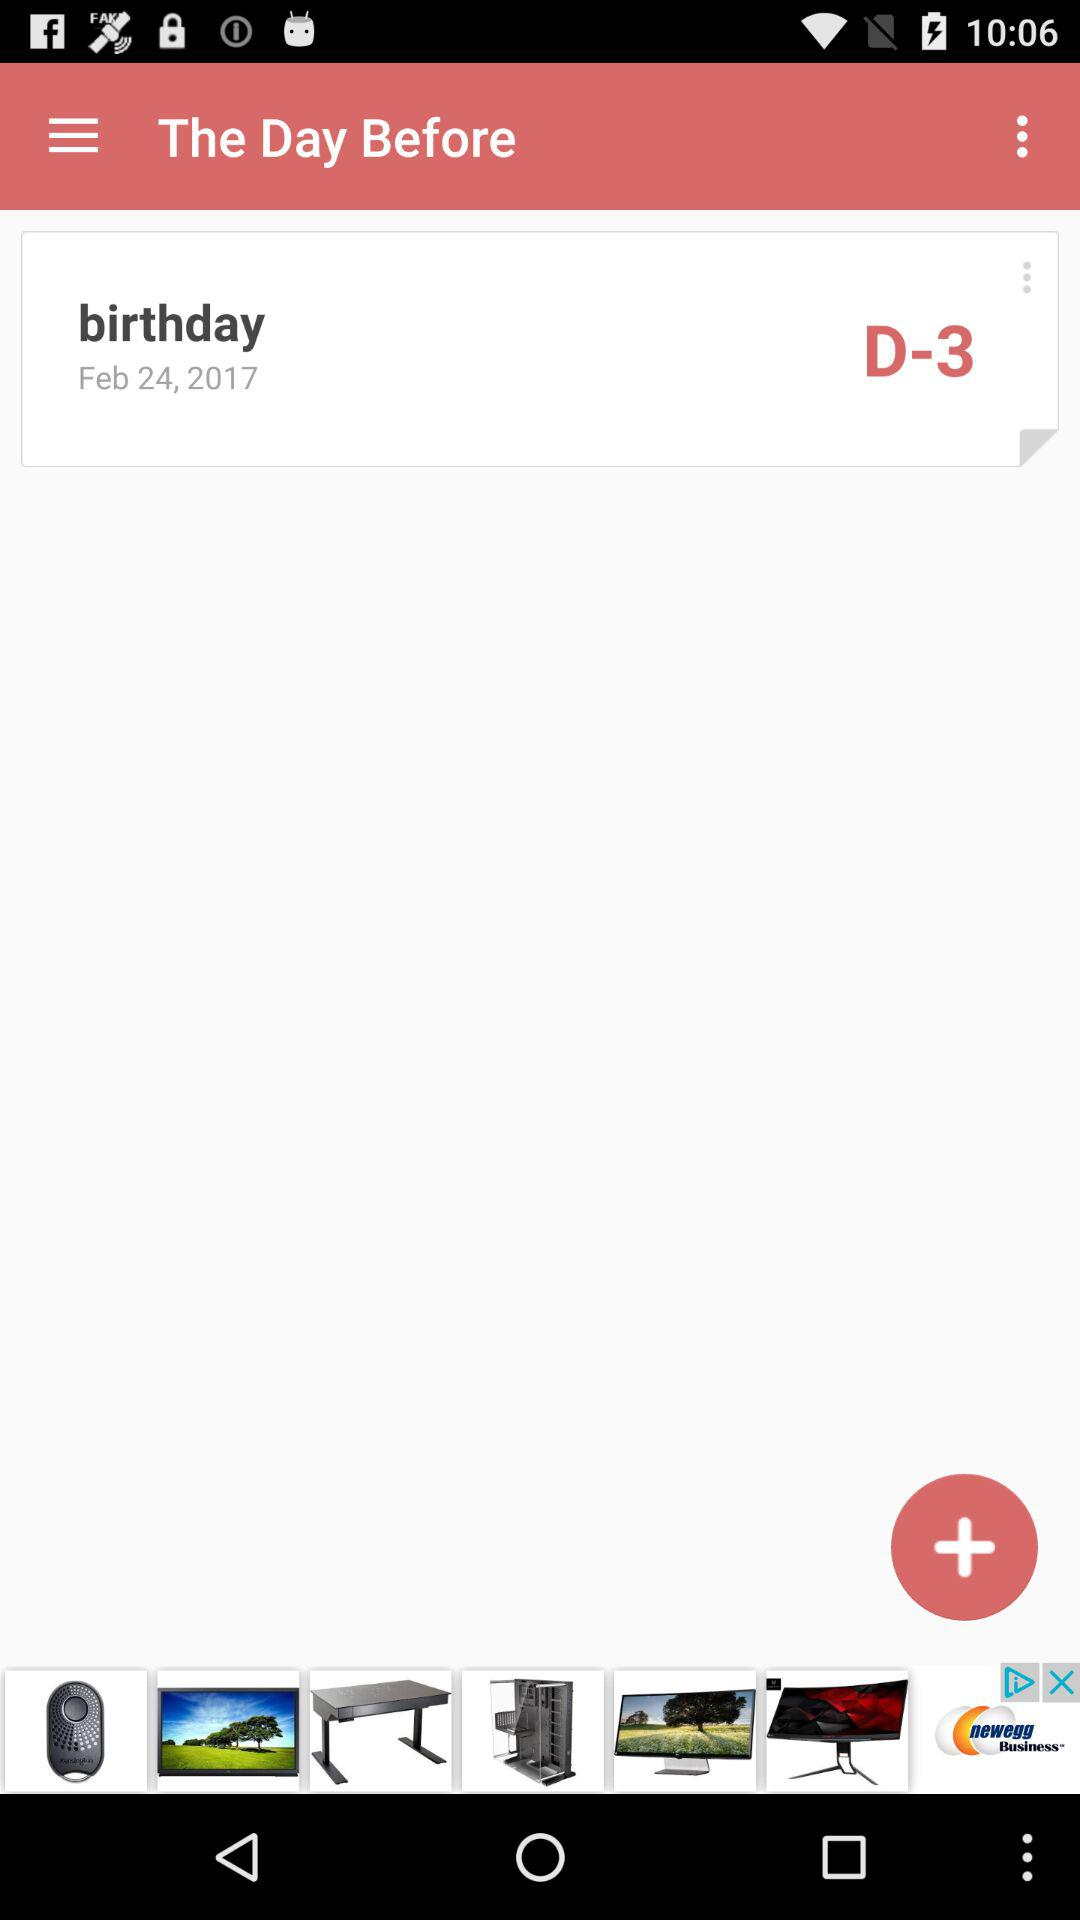How many days are left until the birthday?
Answer the question using a single word or phrase. 3 